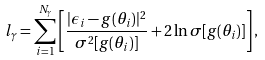<formula> <loc_0><loc_0><loc_500><loc_500>l _ { \gamma } = \sum _ { i = 1 } ^ { N _ { \gamma } } \left [ \frac { | \epsilon _ { i } - g ( \theta _ { i } ) | ^ { 2 } } { \sigma ^ { 2 } [ g ( \theta _ { i } ) ] } + 2 \ln \sigma [ g ( \theta _ { i } ) ] \right ] ,</formula> 